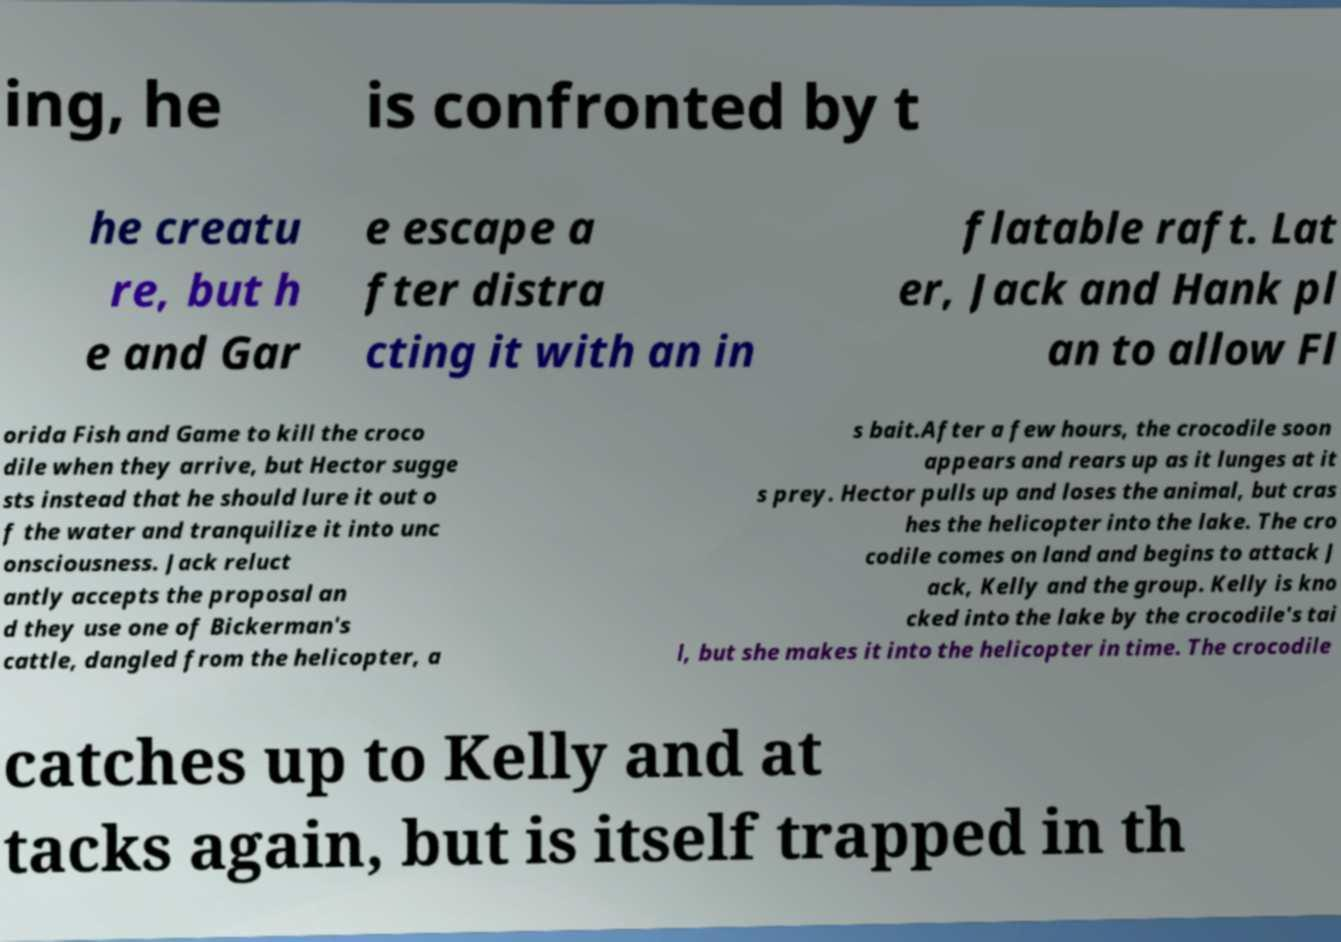Could you extract and type out the text from this image? ing, he is confronted by t he creatu re, but h e and Gar e escape a fter distra cting it with an in flatable raft. Lat er, Jack and Hank pl an to allow Fl orida Fish and Game to kill the croco dile when they arrive, but Hector sugge sts instead that he should lure it out o f the water and tranquilize it into unc onsciousness. Jack reluct antly accepts the proposal an d they use one of Bickerman's cattle, dangled from the helicopter, a s bait.After a few hours, the crocodile soon appears and rears up as it lunges at it s prey. Hector pulls up and loses the animal, but cras hes the helicopter into the lake. The cro codile comes on land and begins to attack J ack, Kelly and the group. Kelly is kno cked into the lake by the crocodile's tai l, but she makes it into the helicopter in time. The crocodile catches up to Kelly and at tacks again, but is itself trapped in th 